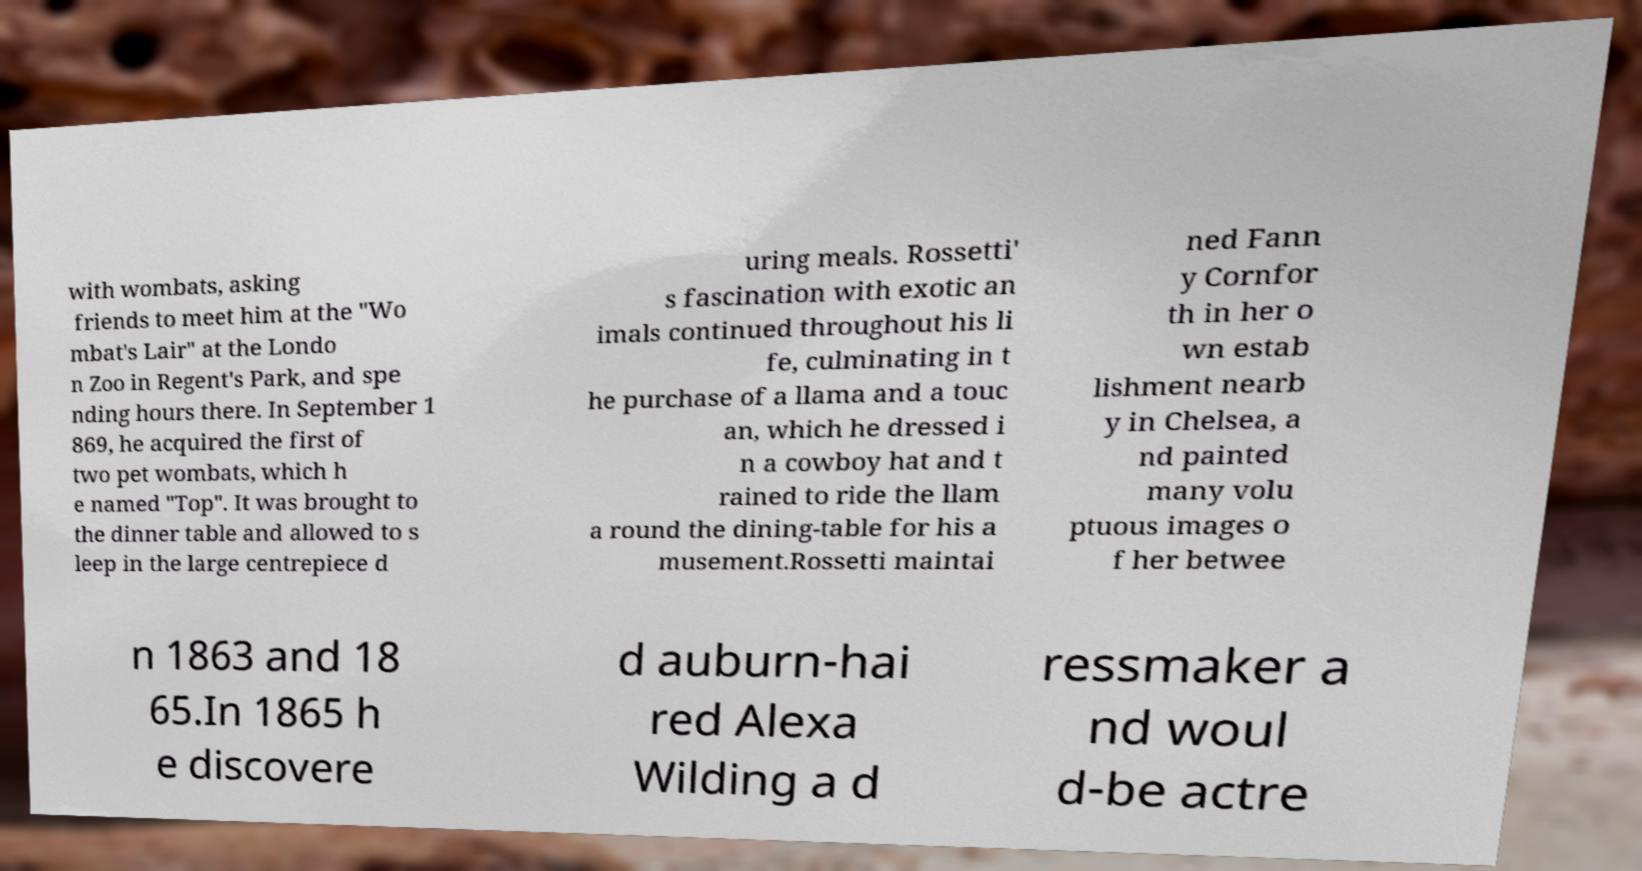Can you read and provide the text displayed in the image?This photo seems to have some interesting text. Can you extract and type it out for me? with wombats, asking friends to meet him at the "Wo mbat's Lair" at the Londo n Zoo in Regent's Park, and spe nding hours there. In September 1 869, he acquired the first of two pet wombats, which h e named "Top". It was brought to the dinner table and allowed to s leep in the large centrepiece d uring meals. Rossetti' s fascination with exotic an imals continued throughout his li fe, culminating in t he purchase of a llama and a touc an, which he dressed i n a cowboy hat and t rained to ride the llam a round the dining-table for his a musement.Rossetti maintai ned Fann y Cornfor th in her o wn estab lishment nearb y in Chelsea, a nd painted many volu ptuous images o f her betwee n 1863 and 18 65.In 1865 h e discovere d auburn-hai red Alexa Wilding a d ressmaker a nd woul d-be actre 